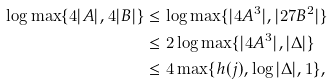<formula> <loc_0><loc_0><loc_500><loc_500>\log \max \{ 4 | A | , 4 | B | \} & \leq \log \max \{ | 4 A ^ { 3 } | , | 2 7 B ^ { 2 } | \} \\ & \leq 2 \log \max \{ | 4 A ^ { 3 } | , | \Delta | \} \\ & \leq 4 \max \{ h ( j ) , \log | \Delta | , 1 \} ,</formula> 